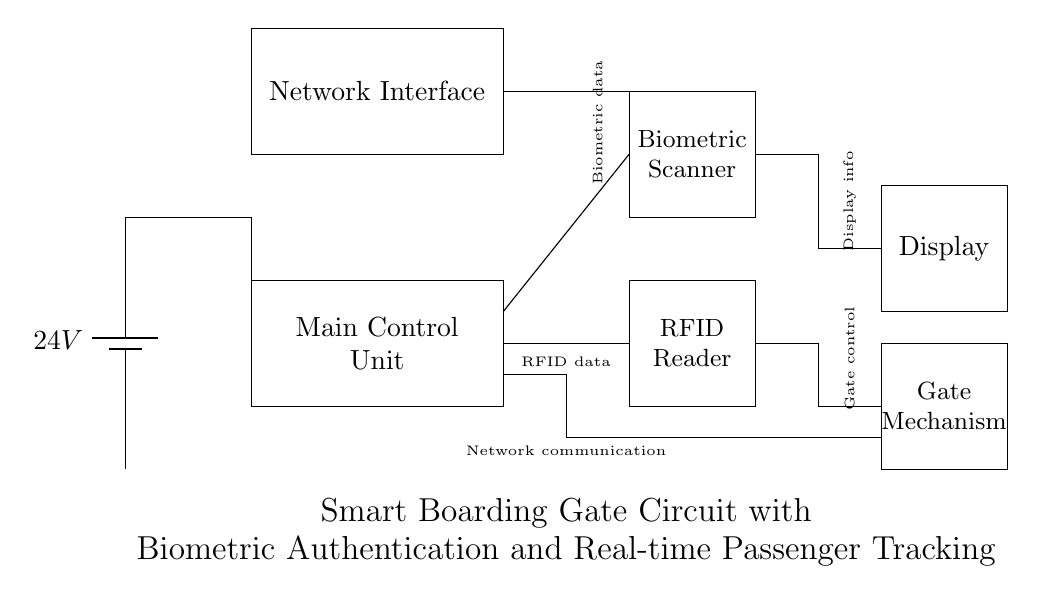What is the voltage in this circuit? The voltage is 24 volts, as indicated by the battery symbol labeled with this value at the top left corner of the circuit diagram.
Answer: 24 volts What component is responsible for biometric data capture? The biometric scanner, located at the top right of the diagram, is designated for capturing biometric data, as indicated in the text within its rectangle.
Answer: Biometric scanner What type of data does the RFID reader handle? The RFID reader at the bottom right of the diagram processes RFID data, as indicated by the labeling within its rectangular area.
Answer: RFID data How many main functional components are in the circuit? There are five main components in the circuit: the main control unit, biometric scanner, RFID reader, display, and gate mechanism. This is determined by counting the labeled rectangles in the diagram.
Answer: Five Which component controls the physical gate mechanism? The gate mechanism component, located at the bottom right corner of the diagram, is identified by the label inside its rectangle.
Answer: Gate mechanism What kind of connection links the network interface to the main control unit? The connection is a data communication link, which is depicted with lines connecting the network interface to the main control unit. This indicates they are part of the same control system.
Answer: Data communication What is the purpose of the display in this circuit? The display serves to show information, as indicated by its label, which is directly connected to the main control unit and receives processed data outputs.
Answer: Display information 